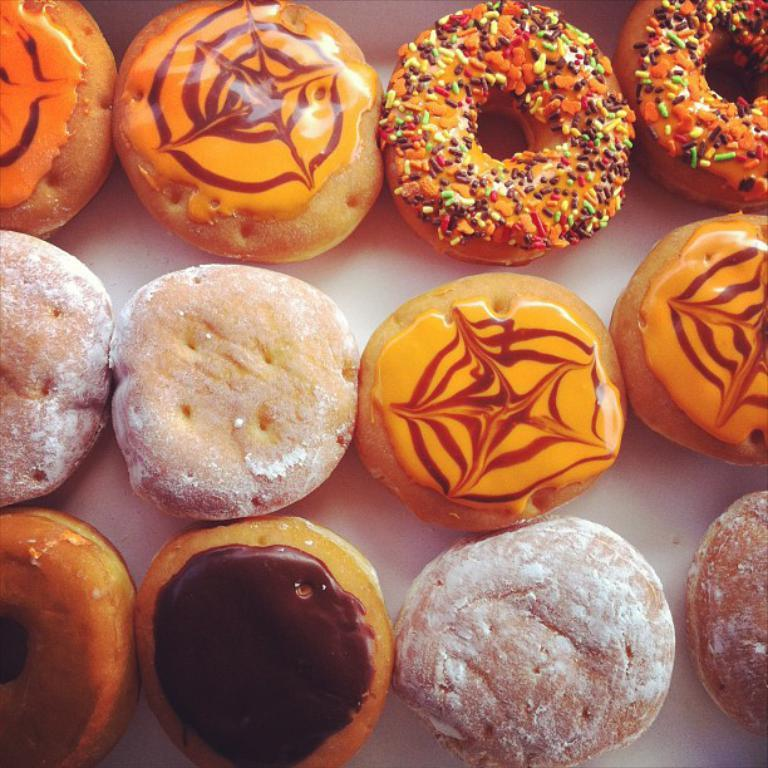What type of food can be seen in the image? There are doughnuts in the image. Can you describe the surface where the doughnuts are placed? The surface the doughnuts and food are on is white. What type of lamp is present in the image? There is no lamp present in the image. Can you describe the temper of the donkey in the image? There is no donkey present in the image. 